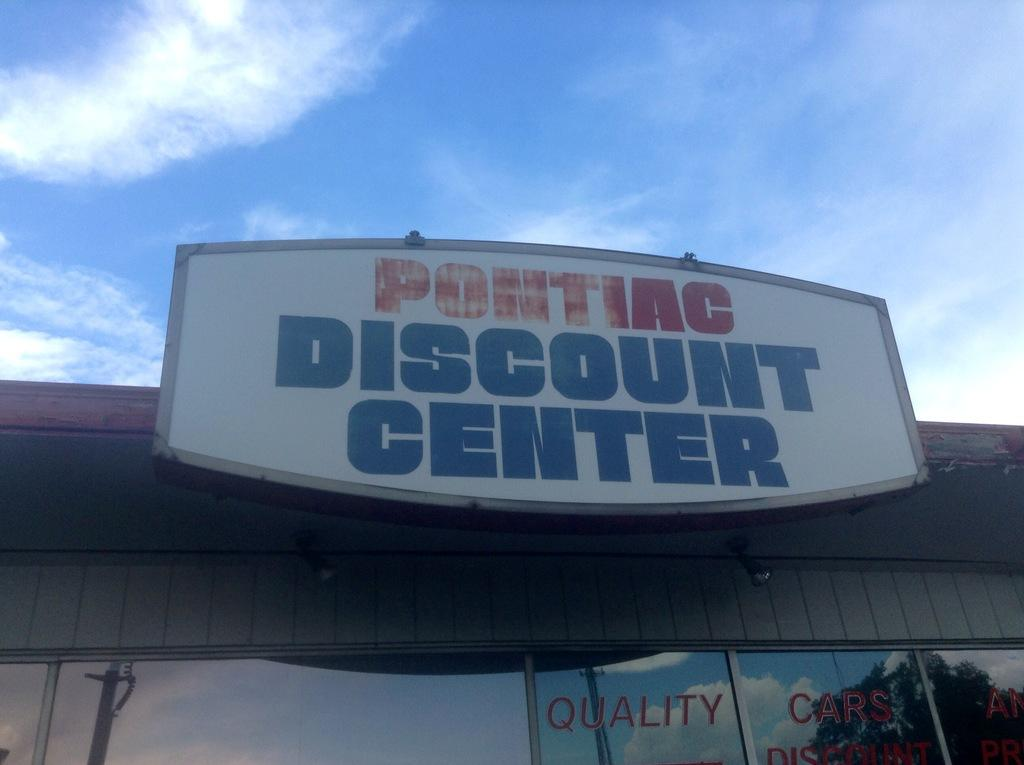<image>
Provide a brief description of the given image. a store front with a sign saying pontiac discount center 